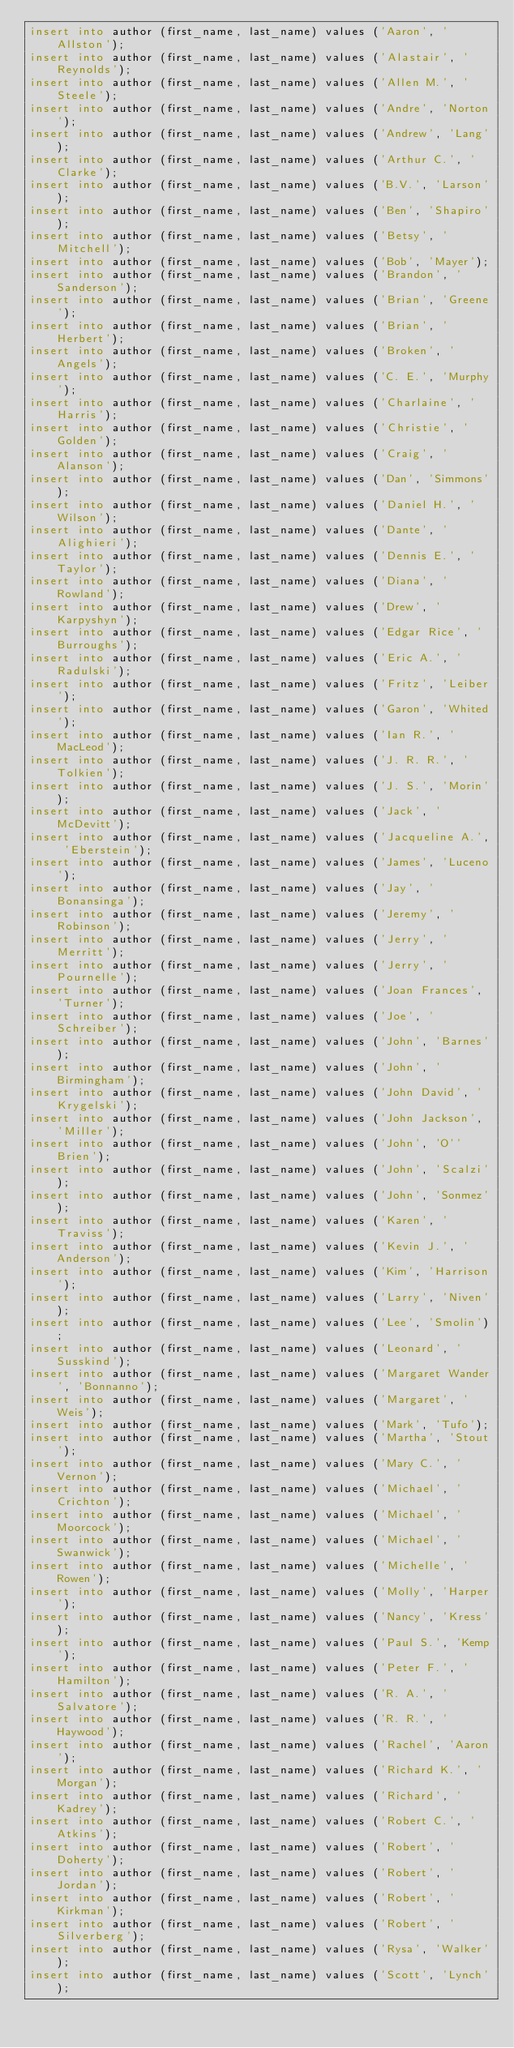<code> <loc_0><loc_0><loc_500><loc_500><_SQL_>insert into author (first_name, last_name) values ('Aaron', 'Allston');
insert into author (first_name, last_name) values ('Alastair', 'Reynolds');
insert into author (first_name, last_name) values ('Allen M.', 'Steele');
insert into author (first_name, last_name) values ('Andre', 'Norton');
insert into author (first_name, last_name) values ('Andrew', 'Lang');
insert into author (first_name, last_name) values ('Arthur C.', 'Clarke');
insert into author (first_name, last_name) values ('B.V.', 'Larson');
insert into author (first_name, last_name) values ('Ben', 'Shapiro');
insert into author (first_name, last_name) values ('Betsy', 'Mitchell');
insert into author (first_name, last_name) values ('Bob', 'Mayer');
insert into author (first_name, last_name) values ('Brandon', 'Sanderson');
insert into author (first_name, last_name) values ('Brian', 'Greene');
insert into author (first_name, last_name) values ('Brian', 'Herbert');
insert into author (first_name, last_name) values ('Broken', 'Angels');
insert into author (first_name, last_name) values ('C. E.', 'Murphy');
insert into author (first_name, last_name) values ('Charlaine', 'Harris');
insert into author (first_name, last_name) values ('Christie', 'Golden');
insert into author (first_name, last_name) values ('Craig', 'Alanson');
insert into author (first_name, last_name) values ('Dan', 'Simmons');
insert into author (first_name, last_name) values ('Daniel H.', 'Wilson');
insert into author (first_name, last_name) values ('Dante', 'Alighieri');
insert into author (first_name, last_name) values ('Dennis E.', 'Taylor');
insert into author (first_name, last_name) values ('Diana', 'Rowland');
insert into author (first_name, last_name) values ('Drew', 'Karpyshyn');
insert into author (first_name, last_name) values ('Edgar Rice', 'Burroughs');
insert into author (first_name, last_name) values ('Eric A.', 'Radulski');
insert into author (first_name, last_name) values ('Fritz', 'Leiber');
insert into author (first_name, last_name) values ('Garon', 'Whited');
insert into author (first_name, last_name) values ('Ian R.', 'MacLeod');
insert into author (first_name, last_name) values ('J. R. R.', 'Tolkien');
insert into author (first_name, last_name) values ('J. S.', 'Morin');
insert into author (first_name, last_name) values ('Jack', 'McDevitt');
insert into author (first_name, last_name) values ('Jacqueline A.', 'Eberstein');
insert into author (first_name, last_name) values ('James', 'Luceno');
insert into author (first_name, last_name) values ('Jay', 'Bonansinga');
insert into author (first_name, last_name) values ('Jeremy', 'Robinson');
insert into author (first_name, last_name) values ('Jerry', 'Merritt');
insert into author (first_name, last_name) values ('Jerry', 'Pournelle');
insert into author (first_name, last_name) values ('Joan Frances', 'Turner');
insert into author (first_name, last_name) values ('Joe', 'Schreiber');
insert into author (first_name, last_name) values ('John', 'Barnes');
insert into author (first_name, last_name) values ('John', 'Birmingham');
insert into author (first_name, last_name) values ('John David', 'Krygelski');
insert into author (first_name, last_name) values ('John Jackson', 'Miller');
insert into author (first_name, last_name) values ('John', 'O''Brien');
insert into author (first_name, last_name) values ('John', 'Scalzi');
insert into author (first_name, last_name) values ('John', 'Sonmez');
insert into author (first_name, last_name) values ('Karen', 'Traviss');
insert into author (first_name, last_name) values ('Kevin J.', 'Anderson');
insert into author (first_name, last_name) values ('Kim', 'Harrison');
insert into author (first_name, last_name) values ('Larry', 'Niven');
insert into author (first_name, last_name) values ('Lee', 'Smolin');
insert into author (first_name, last_name) values ('Leonard', 'Susskind');
insert into author (first_name, last_name) values ('Margaret Wander', 'Bonnanno');
insert into author (first_name, last_name) values ('Margaret', 'Weis');
insert into author (first_name, last_name) values ('Mark', 'Tufo');
insert into author (first_name, last_name) values ('Martha', 'Stout');
insert into author (first_name, last_name) values ('Mary C.', 'Vernon');
insert into author (first_name, last_name) values ('Michael', 'Crichton');
insert into author (first_name, last_name) values ('Michael', 'Moorcock');
insert into author (first_name, last_name) values ('Michael', 'Swanwick');
insert into author (first_name, last_name) values ('Michelle', 'Rowen');
insert into author (first_name, last_name) values ('Molly', 'Harper');
insert into author (first_name, last_name) values ('Nancy', 'Kress');
insert into author (first_name, last_name) values ('Paul S.', 'Kemp');
insert into author (first_name, last_name) values ('Peter F.', 'Hamilton');
insert into author (first_name, last_name) values ('R. A.', 'Salvatore');
insert into author (first_name, last_name) values ('R. R.', 'Haywood');
insert into author (first_name, last_name) values ('Rachel', 'Aaron');
insert into author (first_name, last_name) values ('Richard K.', 'Morgan');
insert into author (first_name, last_name) values ('Richard', 'Kadrey');
insert into author (first_name, last_name) values ('Robert C.', 'Atkins');
insert into author (first_name, last_name) values ('Robert', 'Doherty');
insert into author (first_name, last_name) values ('Robert', 'Jordan');
insert into author (first_name, last_name) values ('Robert', 'Kirkman');
insert into author (first_name, last_name) values ('Robert', 'Silverberg');
insert into author (first_name, last_name) values ('Rysa', 'Walker');
insert into author (first_name, last_name) values ('Scott', 'Lynch');</code> 